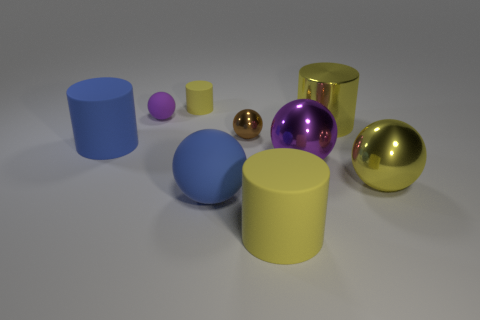Subtract all blue balls. How many yellow cylinders are left? 3 Subtract all purple metallic balls. How many balls are left? 4 Subtract all brown balls. How many balls are left? 4 Subtract 2 spheres. How many spheres are left? 3 Subtract all gray balls. Subtract all gray cubes. How many balls are left? 5 Add 1 purple shiny spheres. How many objects exist? 10 Subtract all cylinders. How many objects are left? 5 Add 4 big balls. How many big balls are left? 7 Add 6 brown metallic cubes. How many brown metallic cubes exist? 6 Subtract 0 brown cylinders. How many objects are left? 9 